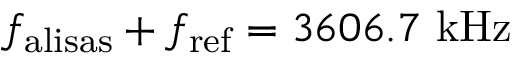Convert formula to latex. <formula><loc_0><loc_0><loc_500><loc_500>f _ { a l i s a s } + f _ { r e f } = 3 6 0 6 . 7 k H z</formula> 